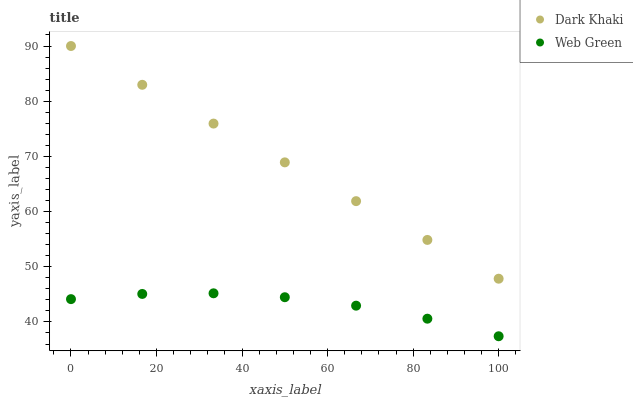Does Web Green have the minimum area under the curve?
Answer yes or no. Yes. Does Dark Khaki have the maximum area under the curve?
Answer yes or no. Yes. Does Web Green have the maximum area under the curve?
Answer yes or no. No. Is Dark Khaki the smoothest?
Answer yes or no. Yes. Is Web Green the roughest?
Answer yes or no. Yes. Is Web Green the smoothest?
Answer yes or no. No. Does Web Green have the lowest value?
Answer yes or no. Yes. Does Dark Khaki have the highest value?
Answer yes or no. Yes. Does Web Green have the highest value?
Answer yes or no. No. Is Web Green less than Dark Khaki?
Answer yes or no. Yes. Is Dark Khaki greater than Web Green?
Answer yes or no. Yes. Does Web Green intersect Dark Khaki?
Answer yes or no. No. 